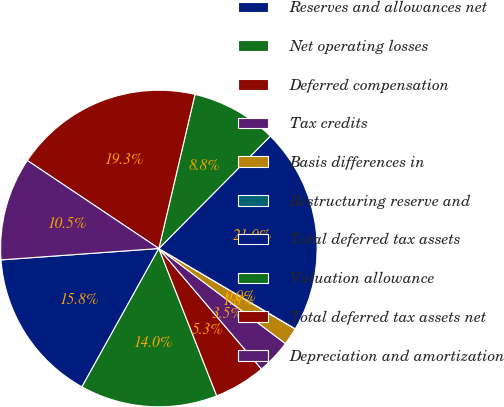Convert chart. <chart><loc_0><loc_0><loc_500><loc_500><pie_chart><fcel>Reserves and allowances net<fcel>Net operating losses<fcel>Deferred compensation<fcel>Tax credits<fcel>Basis differences in<fcel>Restructuring reserve and<fcel>Total deferred tax assets<fcel>Valuation allowance<fcel>Total deferred tax assets net<fcel>Depreciation and amortization<nl><fcel>15.78%<fcel>14.03%<fcel>5.27%<fcel>3.52%<fcel>1.77%<fcel>0.02%<fcel>21.03%<fcel>8.77%<fcel>19.28%<fcel>10.53%<nl></chart> 